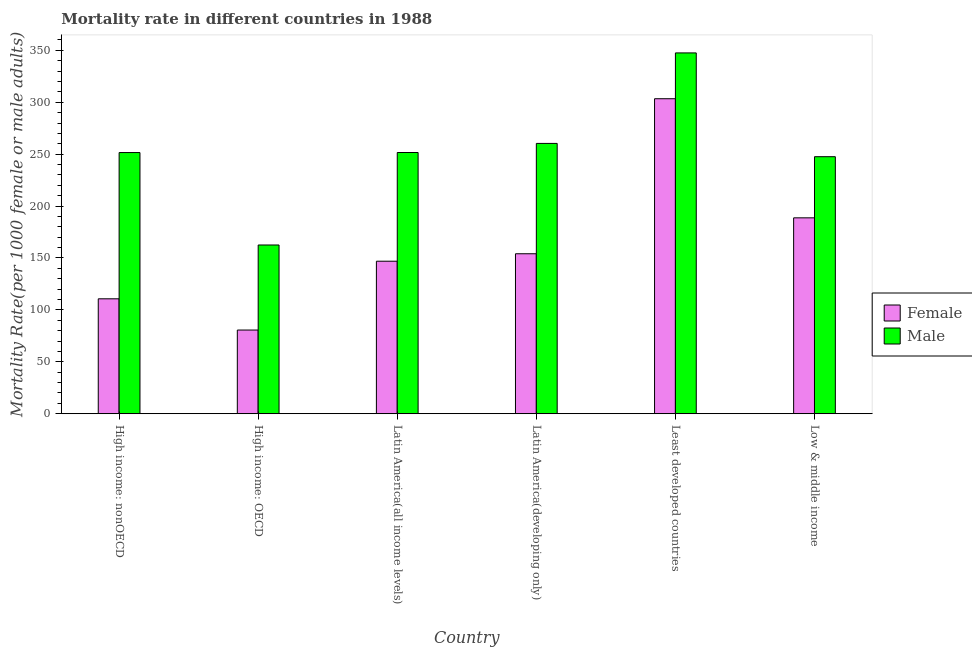How many different coloured bars are there?
Ensure brevity in your answer.  2. How many groups of bars are there?
Ensure brevity in your answer.  6. What is the male mortality rate in High income: nonOECD?
Keep it short and to the point. 251.55. Across all countries, what is the maximum female mortality rate?
Make the answer very short. 303.4. Across all countries, what is the minimum male mortality rate?
Your response must be concise. 162.53. In which country was the female mortality rate maximum?
Provide a succinct answer. Least developed countries. In which country was the female mortality rate minimum?
Offer a very short reply. High income: OECD. What is the total male mortality rate in the graph?
Make the answer very short. 1521.14. What is the difference between the male mortality rate in High income: OECD and that in Least developed countries?
Provide a short and direct response. -185. What is the difference between the male mortality rate in High income: OECD and the female mortality rate in Low & middle income?
Ensure brevity in your answer.  -26.16. What is the average male mortality rate per country?
Ensure brevity in your answer.  253.52. What is the difference between the female mortality rate and male mortality rate in Latin America(all income levels)?
Offer a very short reply. -104.7. What is the ratio of the male mortality rate in High income: nonOECD to that in Latin America(all income levels)?
Provide a short and direct response. 1. Is the difference between the male mortality rate in Latin America(developing only) and Least developed countries greater than the difference between the female mortality rate in Latin America(developing only) and Least developed countries?
Offer a very short reply. Yes. What is the difference between the highest and the second highest female mortality rate?
Your response must be concise. 114.72. What is the difference between the highest and the lowest female mortality rate?
Your answer should be compact. 222.78. In how many countries, is the female mortality rate greater than the average female mortality rate taken over all countries?
Offer a terse response. 2. How many bars are there?
Give a very brief answer. 12. What is the difference between two consecutive major ticks on the Y-axis?
Ensure brevity in your answer.  50. Where does the legend appear in the graph?
Give a very brief answer. Center right. What is the title of the graph?
Keep it short and to the point. Mortality rate in different countries in 1988. What is the label or title of the X-axis?
Keep it short and to the point. Country. What is the label or title of the Y-axis?
Provide a short and direct response. Mortality Rate(per 1000 female or male adults). What is the Mortality Rate(per 1000 female or male adults) in Female in High income: nonOECD?
Give a very brief answer. 110.69. What is the Mortality Rate(per 1000 female or male adults) of Male in High income: nonOECD?
Your answer should be compact. 251.55. What is the Mortality Rate(per 1000 female or male adults) in Female in High income: OECD?
Make the answer very short. 80.62. What is the Mortality Rate(per 1000 female or male adults) in Male in High income: OECD?
Provide a short and direct response. 162.53. What is the Mortality Rate(per 1000 female or male adults) of Female in Latin America(all income levels)?
Your response must be concise. 146.91. What is the Mortality Rate(per 1000 female or male adults) in Male in Latin America(all income levels)?
Offer a terse response. 251.61. What is the Mortality Rate(per 1000 female or male adults) in Female in Latin America(developing only)?
Provide a succinct answer. 154.09. What is the Mortality Rate(per 1000 female or male adults) of Male in Latin America(developing only)?
Provide a short and direct response. 260.35. What is the Mortality Rate(per 1000 female or male adults) in Female in Least developed countries?
Your answer should be very brief. 303.4. What is the Mortality Rate(per 1000 female or male adults) of Male in Least developed countries?
Your answer should be very brief. 347.52. What is the Mortality Rate(per 1000 female or male adults) in Female in Low & middle income?
Offer a terse response. 188.68. What is the Mortality Rate(per 1000 female or male adults) of Male in Low & middle income?
Your answer should be compact. 247.58. Across all countries, what is the maximum Mortality Rate(per 1000 female or male adults) in Female?
Offer a very short reply. 303.4. Across all countries, what is the maximum Mortality Rate(per 1000 female or male adults) of Male?
Your response must be concise. 347.52. Across all countries, what is the minimum Mortality Rate(per 1000 female or male adults) in Female?
Keep it short and to the point. 80.62. Across all countries, what is the minimum Mortality Rate(per 1000 female or male adults) in Male?
Your answer should be compact. 162.53. What is the total Mortality Rate(per 1000 female or male adults) of Female in the graph?
Offer a very short reply. 984.39. What is the total Mortality Rate(per 1000 female or male adults) of Male in the graph?
Offer a terse response. 1521.14. What is the difference between the Mortality Rate(per 1000 female or male adults) in Female in High income: nonOECD and that in High income: OECD?
Ensure brevity in your answer.  30.07. What is the difference between the Mortality Rate(per 1000 female or male adults) in Male in High income: nonOECD and that in High income: OECD?
Provide a succinct answer. 89.03. What is the difference between the Mortality Rate(per 1000 female or male adults) in Female in High income: nonOECD and that in Latin America(all income levels)?
Your answer should be compact. -36.22. What is the difference between the Mortality Rate(per 1000 female or male adults) of Male in High income: nonOECD and that in Latin America(all income levels)?
Keep it short and to the point. -0.05. What is the difference between the Mortality Rate(per 1000 female or male adults) of Female in High income: nonOECD and that in Latin America(developing only)?
Make the answer very short. -43.4. What is the difference between the Mortality Rate(per 1000 female or male adults) of Male in High income: nonOECD and that in Latin America(developing only)?
Provide a succinct answer. -8.8. What is the difference between the Mortality Rate(per 1000 female or male adults) in Female in High income: nonOECD and that in Least developed countries?
Your answer should be compact. -192.71. What is the difference between the Mortality Rate(per 1000 female or male adults) of Male in High income: nonOECD and that in Least developed countries?
Your answer should be compact. -95.97. What is the difference between the Mortality Rate(per 1000 female or male adults) in Female in High income: nonOECD and that in Low & middle income?
Offer a very short reply. -77.99. What is the difference between the Mortality Rate(per 1000 female or male adults) of Male in High income: nonOECD and that in Low & middle income?
Your response must be concise. 3.98. What is the difference between the Mortality Rate(per 1000 female or male adults) of Female in High income: OECD and that in Latin America(all income levels)?
Give a very brief answer. -66.29. What is the difference between the Mortality Rate(per 1000 female or male adults) in Male in High income: OECD and that in Latin America(all income levels)?
Offer a terse response. -89.08. What is the difference between the Mortality Rate(per 1000 female or male adults) in Female in High income: OECD and that in Latin America(developing only)?
Ensure brevity in your answer.  -73.47. What is the difference between the Mortality Rate(per 1000 female or male adults) of Male in High income: OECD and that in Latin America(developing only)?
Make the answer very short. -97.83. What is the difference between the Mortality Rate(per 1000 female or male adults) in Female in High income: OECD and that in Least developed countries?
Ensure brevity in your answer.  -222.78. What is the difference between the Mortality Rate(per 1000 female or male adults) in Male in High income: OECD and that in Least developed countries?
Make the answer very short. -185. What is the difference between the Mortality Rate(per 1000 female or male adults) of Female in High income: OECD and that in Low & middle income?
Provide a short and direct response. -108.06. What is the difference between the Mortality Rate(per 1000 female or male adults) of Male in High income: OECD and that in Low & middle income?
Your answer should be very brief. -85.05. What is the difference between the Mortality Rate(per 1000 female or male adults) in Female in Latin America(all income levels) and that in Latin America(developing only)?
Your answer should be very brief. -7.18. What is the difference between the Mortality Rate(per 1000 female or male adults) of Male in Latin America(all income levels) and that in Latin America(developing only)?
Your answer should be compact. -8.75. What is the difference between the Mortality Rate(per 1000 female or male adults) of Female in Latin America(all income levels) and that in Least developed countries?
Provide a short and direct response. -156.49. What is the difference between the Mortality Rate(per 1000 female or male adults) of Male in Latin America(all income levels) and that in Least developed countries?
Provide a short and direct response. -95.92. What is the difference between the Mortality Rate(per 1000 female or male adults) of Female in Latin America(all income levels) and that in Low & middle income?
Provide a short and direct response. -41.77. What is the difference between the Mortality Rate(per 1000 female or male adults) in Male in Latin America(all income levels) and that in Low & middle income?
Provide a succinct answer. 4.03. What is the difference between the Mortality Rate(per 1000 female or male adults) in Female in Latin America(developing only) and that in Least developed countries?
Provide a succinct answer. -149.32. What is the difference between the Mortality Rate(per 1000 female or male adults) of Male in Latin America(developing only) and that in Least developed countries?
Give a very brief answer. -87.17. What is the difference between the Mortality Rate(per 1000 female or male adults) in Female in Latin America(developing only) and that in Low & middle income?
Offer a very short reply. -34.6. What is the difference between the Mortality Rate(per 1000 female or male adults) of Male in Latin America(developing only) and that in Low & middle income?
Your response must be concise. 12.78. What is the difference between the Mortality Rate(per 1000 female or male adults) in Female in Least developed countries and that in Low & middle income?
Give a very brief answer. 114.72. What is the difference between the Mortality Rate(per 1000 female or male adults) of Male in Least developed countries and that in Low & middle income?
Your response must be concise. 99.95. What is the difference between the Mortality Rate(per 1000 female or male adults) in Female in High income: nonOECD and the Mortality Rate(per 1000 female or male adults) in Male in High income: OECD?
Provide a short and direct response. -51.84. What is the difference between the Mortality Rate(per 1000 female or male adults) in Female in High income: nonOECD and the Mortality Rate(per 1000 female or male adults) in Male in Latin America(all income levels)?
Offer a very short reply. -140.92. What is the difference between the Mortality Rate(per 1000 female or male adults) of Female in High income: nonOECD and the Mortality Rate(per 1000 female or male adults) of Male in Latin America(developing only)?
Provide a succinct answer. -149.66. What is the difference between the Mortality Rate(per 1000 female or male adults) of Female in High income: nonOECD and the Mortality Rate(per 1000 female or male adults) of Male in Least developed countries?
Provide a short and direct response. -236.83. What is the difference between the Mortality Rate(per 1000 female or male adults) of Female in High income: nonOECD and the Mortality Rate(per 1000 female or male adults) of Male in Low & middle income?
Your answer should be compact. -136.88. What is the difference between the Mortality Rate(per 1000 female or male adults) in Female in High income: OECD and the Mortality Rate(per 1000 female or male adults) in Male in Latin America(all income levels)?
Provide a succinct answer. -170.99. What is the difference between the Mortality Rate(per 1000 female or male adults) in Female in High income: OECD and the Mortality Rate(per 1000 female or male adults) in Male in Latin America(developing only)?
Keep it short and to the point. -179.73. What is the difference between the Mortality Rate(per 1000 female or male adults) in Female in High income: OECD and the Mortality Rate(per 1000 female or male adults) in Male in Least developed countries?
Your answer should be very brief. -266.9. What is the difference between the Mortality Rate(per 1000 female or male adults) in Female in High income: OECD and the Mortality Rate(per 1000 female or male adults) in Male in Low & middle income?
Offer a very short reply. -166.96. What is the difference between the Mortality Rate(per 1000 female or male adults) of Female in Latin America(all income levels) and the Mortality Rate(per 1000 female or male adults) of Male in Latin America(developing only)?
Keep it short and to the point. -113.44. What is the difference between the Mortality Rate(per 1000 female or male adults) of Female in Latin America(all income levels) and the Mortality Rate(per 1000 female or male adults) of Male in Least developed countries?
Offer a very short reply. -200.61. What is the difference between the Mortality Rate(per 1000 female or male adults) of Female in Latin America(all income levels) and the Mortality Rate(per 1000 female or male adults) of Male in Low & middle income?
Offer a very short reply. -100.67. What is the difference between the Mortality Rate(per 1000 female or male adults) in Female in Latin America(developing only) and the Mortality Rate(per 1000 female or male adults) in Male in Least developed countries?
Your answer should be very brief. -193.44. What is the difference between the Mortality Rate(per 1000 female or male adults) in Female in Latin America(developing only) and the Mortality Rate(per 1000 female or male adults) in Male in Low & middle income?
Offer a terse response. -93.49. What is the difference between the Mortality Rate(per 1000 female or male adults) of Female in Least developed countries and the Mortality Rate(per 1000 female or male adults) of Male in Low & middle income?
Offer a terse response. 55.83. What is the average Mortality Rate(per 1000 female or male adults) of Female per country?
Keep it short and to the point. 164.07. What is the average Mortality Rate(per 1000 female or male adults) of Male per country?
Give a very brief answer. 253.52. What is the difference between the Mortality Rate(per 1000 female or male adults) in Female and Mortality Rate(per 1000 female or male adults) in Male in High income: nonOECD?
Your answer should be very brief. -140.86. What is the difference between the Mortality Rate(per 1000 female or male adults) in Female and Mortality Rate(per 1000 female or male adults) in Male in High income: OECD?
Provide a short and direct response. -81.91. What is the difference between the Mortality Rate(per 1000 female or male adults) in Female and Mortality Rate(per 1000 female or male adults) in Male in Latin America(all income levels)?
Make the answer very short. -104.7. What is the difference between the Mortality Rate(per 1000 female or male adults) of Female and Mortality Rate(per 1000 female or male adults) of Male in Latin America(developing only)?
Make the answer very short. -106.27. What is the difference between the Mortality Rate(per 1000 female or male adults) of Female and Mortality Rate(per 1000 female or male adults) of Male in Least developed countries?
Provide a short and direct response. -44.12. What is the difference between the Mortality Rate(per 1000 female or male adults) in Female and Mortality Rate(per 1000 female or male adults) in Male in Low & middle income?
Provide a short and direct response. -58.89. What is the ratio of the Mortality Rate(per 1000 female or male adults) of Female in High income: nonOECD to that in High income: OECD?
Provide a succinct answer. 1.37. What is the ratio of the Mortality Rate(per 1000 female or male adults) of Male in High income: nonOECD to that in High income: OECD?
Ensure brevity in your answer.  1.55. What is the ratio of the Mortality Rate(per 1000 female or male adults) of Female in High income: nonOECD to that in Latin America(all income levels)?
Keep it short and to the point. 0.75. What is the ratio of the Mortality Rate(per 1000 female or male adults) of Male in High income: nonOECD to that in Latin America(all income levels)?
Your answer should be compact. 1. What is the ratio of the Mortality Rate(per 1000 female or male adults) in Female in High income: nonOECD to that in Latin America(developing only)?
Offer a very short reply. 0.72. What is the ratio of the Mortality Rate(per 1000 female or male adults) of Male in High income: nonOECD to that in Latin America(developing only)?
Ensure brevity in your answer.  0.97. What is the ratio of the Mortality Rate(per 1000 female or male adults) of Female in High income: nonOECD to that in Least developed countries?
Keep it short and to the point. 0.36. What is the ratio of the Mortality Rate(per 1000 female or male adults) of Male in High income: nonOECD to that in Least developed countries?
Provide a short and direct response. 0.72. What is the ratio of the Mortality Rate(per 1000 female or male adults) in Female in High income: nonOECD to that in Low & middle income?
Your answer should be very brief. 0.59. What is the ratio of the Mortality Rate(per 1000 female or male adults) of Male in High income: nonOECD to that in Low & middle income?
Your answer should be compact. 1.02. What is the ratio of the Mortality Rate(per 1000 female or male adults) in Female in High income: OECD to that in Latin America(all income levels)?
Your answer should be very brief. 0.55. What is the ratio of the Mortality Rate(per 1000 female or male adults) in Male in High income: OECD to that in Latin America(all income levels)?
Ensure brevity in your answer.  0.65. What is the ratio of the Mortality Rate(per 1000 female or male adults) of Female in High income: OECD to that in Latin America(developing only)?
Provide a short and direct response. 0.52. What is the ratio of the Mortality Rate(per 1000 female or male adults) of Male in High income: OECD to that in Latin America(developing only)?
Give a very brief answer. 0.62. What is the ratio of the Mortality Rate(per 1000 female or male adults) of Female in High income: OECD to that in Least developed countries?
Keep it short and to the point. 0.27. What is the ratio of the Mortality Rate(per 1000 female or male adults) in Male in High income: OECD to that in Least developed countries?
Make the answer very short. 0.47. What is the ratio of the Mortality Rate(per 1000 female or male adults) of Female in High income: OECD to that in Low & middle income?
Provide a succinct answer. 0.43. What is the ratio of the Mortality Rate(per 1000 female or male adults) in Male in High income: OECD to that in Low & middle income?
Provide a short and direct response. 0.66. What is the ratio of the Mortality Rate(per 1000 female or male adults) of Female in Latin America(all income levels) to that in Latin America(developing only)?
Offer a terse response. 0.95. What is the ratio of the Mortality Rate(per 1000 female or male adults) of Male in Latin America(all income levels) to that in Latin America(developing only)?
Provide a succinct answer. 0.97. What is the ratio of the Mortality Rate(per 1000 female or male adults) in Female in Latin America(all income levels) to that in Least developed countries?
Provide a succinct answer. 0.48. What is the ratio of the Mortality Rate(per 1000 female or male adults) in Male in Latin America(all income levels) to that in Least developed countries?
Keep it short and to the point. 0.72. What is the ratio of the Mortality Rate(per 1000 female or male adults) in Female in Latin America(all income levels) to that in Low & middle income?
Your answer should be compact. 0.78. What is the ratio of the Mortality Rate(per 1000 female or male adults) of Male in Latin America(all income levels) to that in Low & middle income?
Provide a short and direct response. 1.02. What is the ratio of the Mortality Rate(per 1000 female or male adults) in Female in Latin America(developing only) to that in Least developed countries?
Offer a terse response. 0.51. What is the ratio of the Mortality Rate(per 1000 female or male adults) of Male in Latin America(developing only) to that in Least developed countries?
Keep it short and to the point. 0.75. What is the ratio of the Mortality Rate(per 1000 female or male adults) of Female in Latin America(developing only) to that in Low & middle income?
Offer a terse response. 0.82. What is the ratio of the Mortality Rate(per 1000 female or male adults) of Male in Latin America(developing only) to that in Low & middle income?
Provide a succinct answer. 1.05. What is the ratio of the Mortality Rate(per 1000 female or male adults) in Female in Least developed countries to that in Low & middle income?
Your answer should be compact. 1.61. What is the ratio of the Mortality Rate(per 1000 female or male adults) in Male in Least developed countries to that in Low & middle income?
Make the answer very short. 1.4. What is the difference between the highest and the second highest Mortality Rate(per 1000 female or male adults) of Female?
Offer a very short reply. 114.72. What is the difference between the highest and the second highest Mortality Rate(per 1000 female or male adults) of Male?
Your answer should be compact. 87.17. What is the difference between the highest and the lowest Mortality Rate(per 1000 female or male adults) in Female?
Provide a short and direct response. 222.78. What is the difference between the highest and the lowest Mortality Rate(per 1000 female or male adults) of Male?
Provide a succinct answer. 185. 